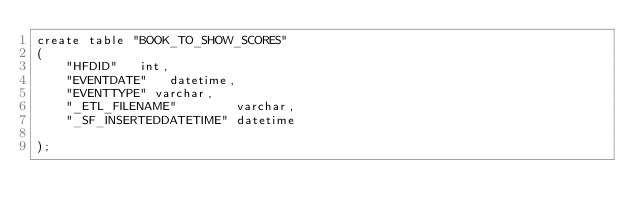<code> <loc_0><loc_0><loc_500><loc_500><_SQL_>create table "BOOK_TO_SHOW_SCORES"
(
    "HFDID"   int,
    "EVENTDATE"   datetime,
    "EVENTTYPE" varchar,
    "_ETL_FILENAME"        varchar,
    "_SF_INSERTEDDATETIME" datetime

);

</code> 